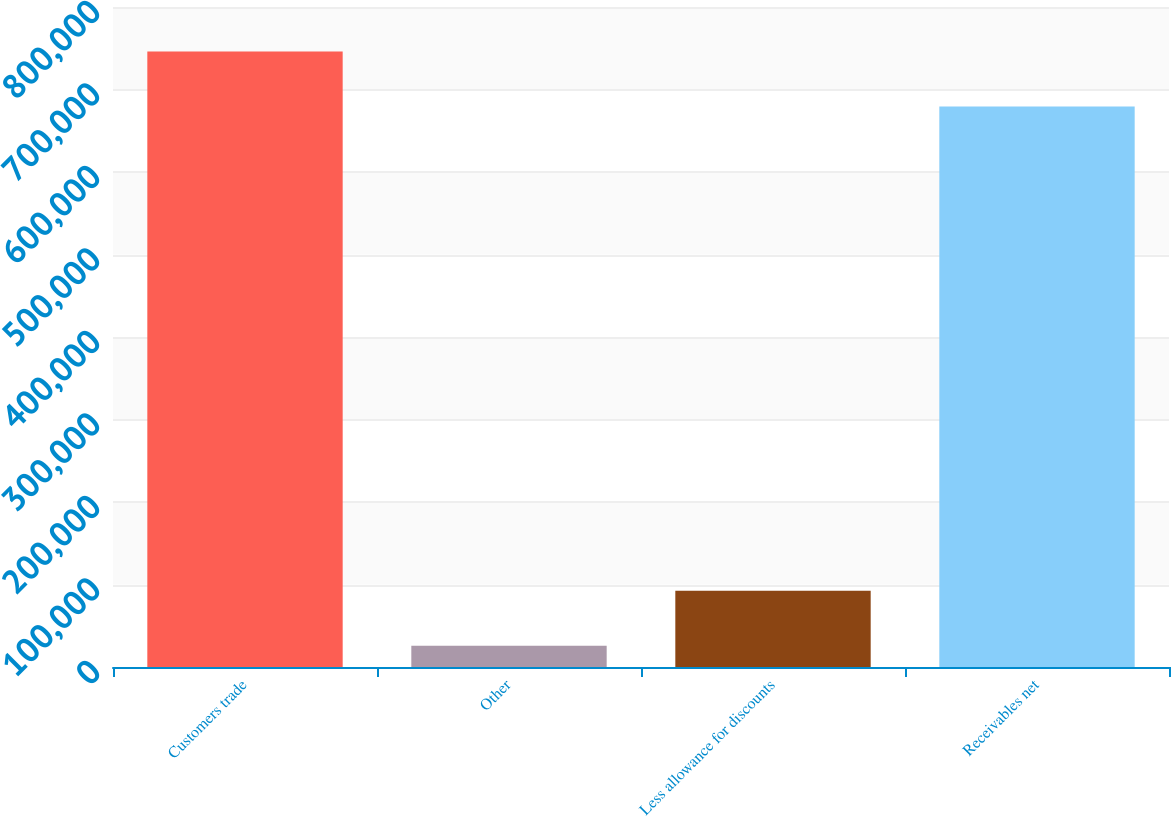<chart> <loc_0><loc_0><loc_500><loc_500><bar_chart><fcel>Customers trade<fcel>Other<fcel>Less allowance for discounts<fcel>Receivables net<nl><fcel>746049<fcel>25793<fcel>92369<fcel>679473<nl></chart> 